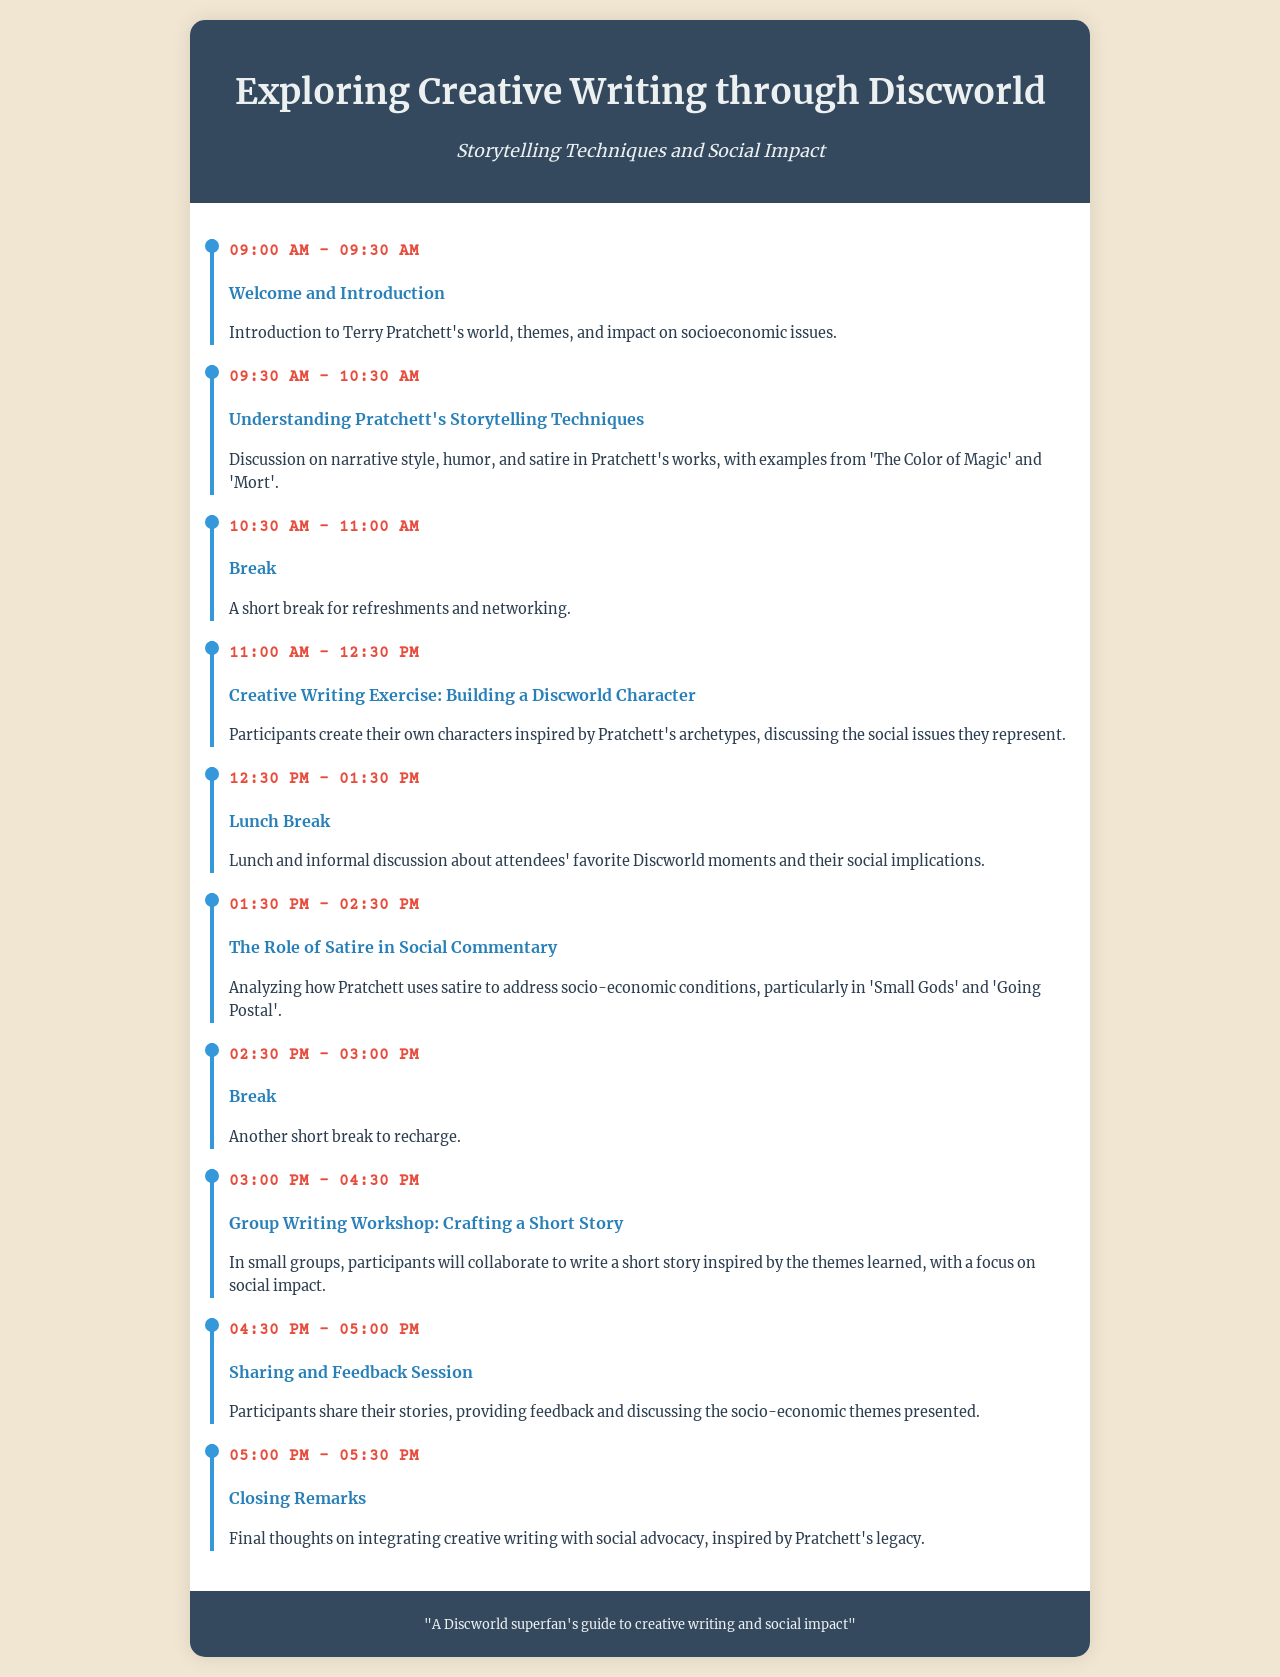What time does the workshop start? The workshop starts at 09:00 AM as indicated in the schedule.
Answer: 09:00 AM What is the title of the first agenda item? The title of the first agenda item is listed in the document under the time 09:00 AM - 09:30 AM.
Answer: Welcome and Introduction Which Discworld book is referenced in the session about storytelling techniques? The session discusses examples from specific Discworld books. One of the books mentioned is 'The Color of Magic.'
Answer: The Color of Magic What activity occurs from 01:30 PM to 02:30 PM? The activity for this time slot focuses on a specific aspect of social commentary in Pratchett's works.
Answer: The Role of Satire in Social Commentary How long is the break after the second session? The break duration between schedule items is specifically noted in the agenda.
Answer: 30 minutes How many character-building exercises are scheduled? The document's agenda outlines a session dedicated to this type of exercise.
Answer: One What is a key theme participants will explore during the group writing workshop? The group writing workshop explicitly mentions focusing on an important aspect during collaboration.
Answer: Social impact What follows the Sharing and Feedback Session? The agenda lists a concluding segment after the feedback session.
Answer: Closing Remarks Which theme does the workshop emphasize in connection with Terry Pratchett? The document highlights the overarching theme related to Pratchett's influence in storytelling.
Answer: Social impact 